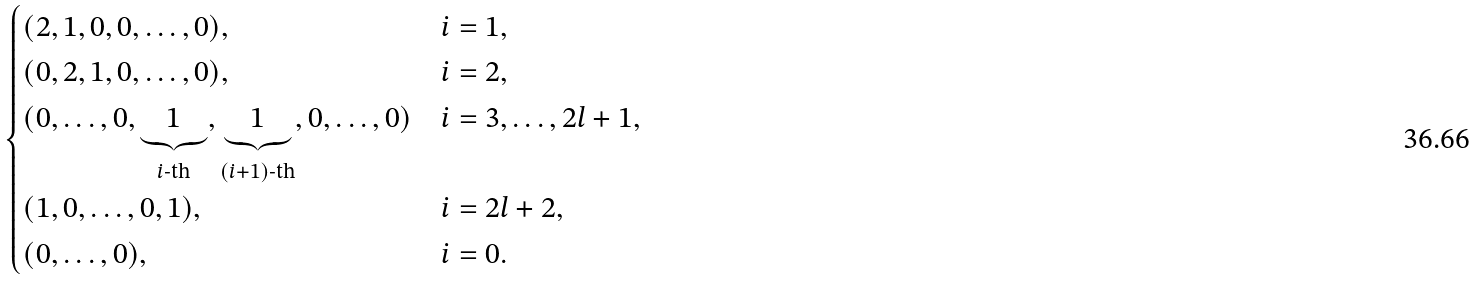Convert formula to latex. <formula><loc_0><loc_0><loc_500><loc_500>\begin{cases} ( 2 , 1 , 0 , 0 , \dots , 0 ) , \quad & i = 1 , \\ ( 0 , 2 , 1 , 0 , \dots , 0 ) , & i = 2 , \\ ( 0 , \dots , 0 , \underbrace { 1 } _ { i \text {-th} } , \underbrace { 1 } _ { { ( i + 1 ) } \text {-th} } , 0 , \dots , 0 ) & i = 3 , \dots , 2 l + 1 , \\ ( 1 , 0 , \dots , 0 , 1 ) , & i = 2 l + 2 , \\ ( 0 , \dots , 0 ) , & i = 0 . \end{cases}</formula> 